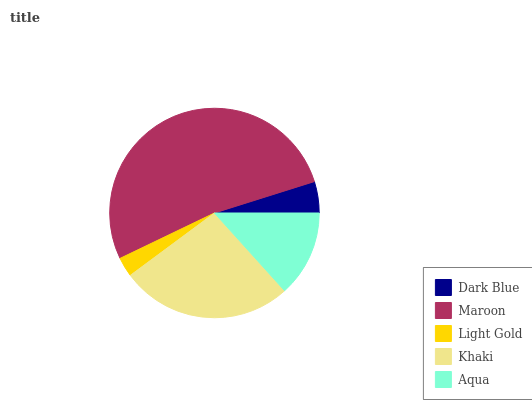Is Light Gold the minimum?
Answer yes or no. Yes. Is Maroon the maximum?
Answer yes or no. Yes. Is Maroon the minimum?
Answer yes or no. No. Is Light Gold the maximum?
Answer yes or no. No. Is Maroon greater than Light Gold?
Answer yes or no. Yes. Is Light Gold less than Maroon?
Answer yes or no. Yes. Is Light Gold greater than Maroon?
Answer yes or no. No. Is Maroon less than Light Gold?
Answer yes or no. No. Is Aqua the high median?
Answer yes or no. Yes. Is Aqua the low median?
Answer yes or no. Yes. Is Light Gold the high median?
Answer yes or no. No. Is Khaki the low median?
Answer yes or no. No. 